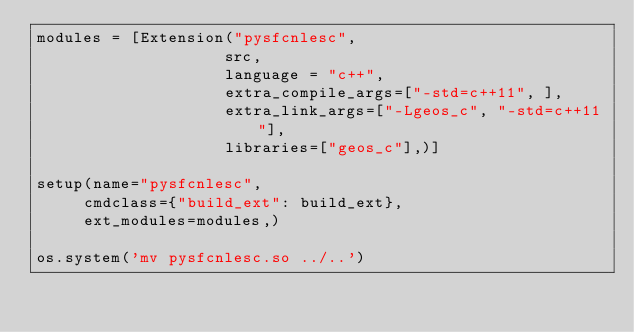<code> <loc_0><loc_0><loc_500><loc_500><_Python_>modules = [Extension("pysfcnlesc",
                    src,
                    language = "c++",
                    extra_compile_args=["-std=c++11", ],
                    extra_link_args=["-Lgeos_c", "-std=c++11"],
                    libraries=["geos_c"],)]

setup(name="pysfcnlesc",
     cmdclass={"build_ext": build_ext},
     ext_modules=modules,)

os.system('mv pysfcnlesc.so ../..')
</code> 